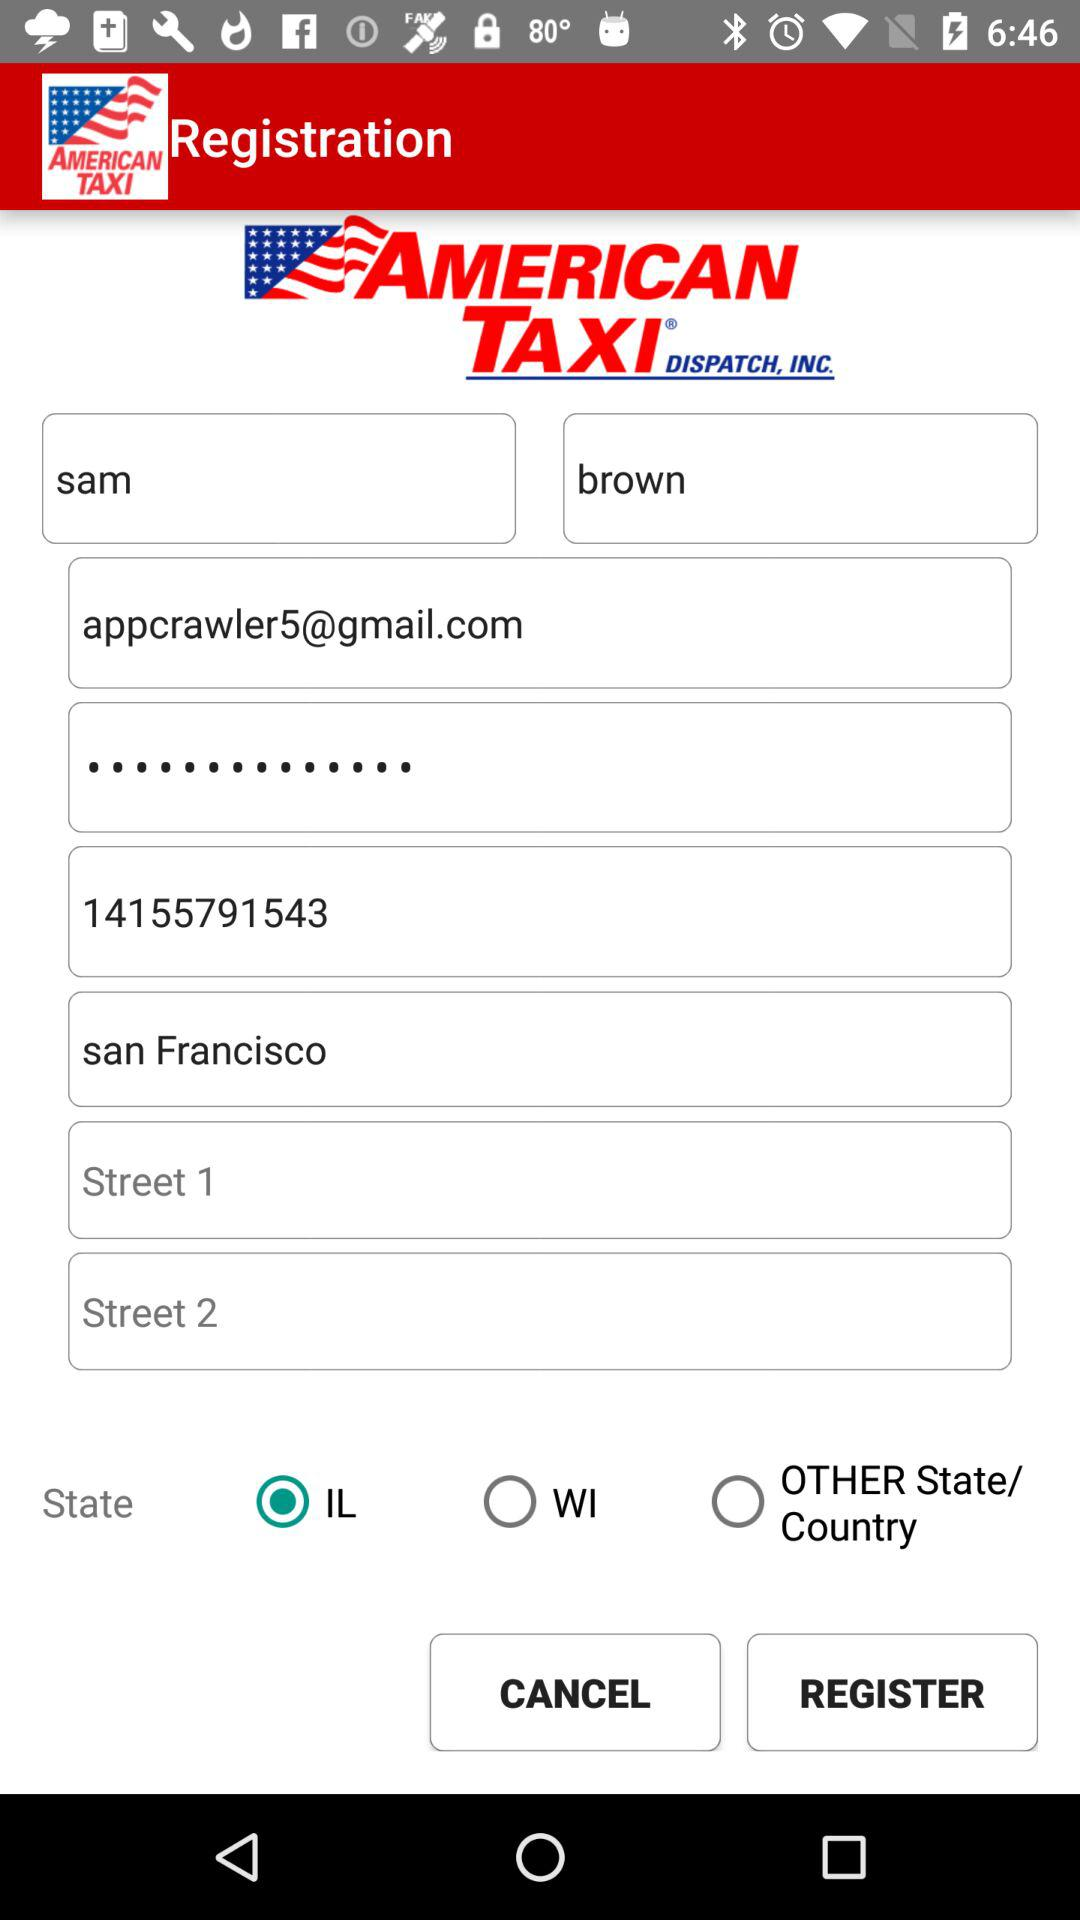What is the first name? The first name is Sam. 